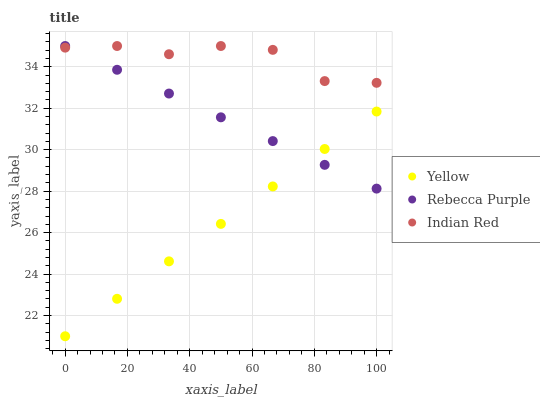Does Yellow have the minimum area under the curve?
Answer yes or no. Yes. Does Indian Red have the maximum area under the curve?
Answer yes or no. Yes. Does Rebecca Purple have the minimum area under the curve?
Answer yes or no. No. Does Rebecca Purple have the maximum area under the curve?
Answer yes or no. No. Is Yellow the smoothest?
Answer yes or no. Yes. Is Indian Red the roughest?
Answer yes or no. Yes. Is Rebecca Purple the smoothest?
Answer yes or no. No. Is Rebecca Purple the roughest?
Answer yes or no. No. Does Yellow have the lowest value?
Answer yes or no. Yes. Does Rebecca Purple have the lowest value?
Answer yes or no. No. Does Rebecca Purple have the highest value?
Answer yes or no. Yes. Does Yellow have the highest value?
Answer yes or no. No. Is Yellow less than Indian Red?
Answer yes or no. Yes. Is Indian Red greater than Yellow?
Answer yes or no. Yes. Does Rebecca Purple intersect Indian Red?
Answer yes or no. Yes. Is Rebecca Purple less than Indian Red?
Answer yes or no. No. Is Rebecca Purple greater than Indian Red?
Answer yes or no. No. Does Yellow intersect Indian Red?
Answer yes or no. No. 